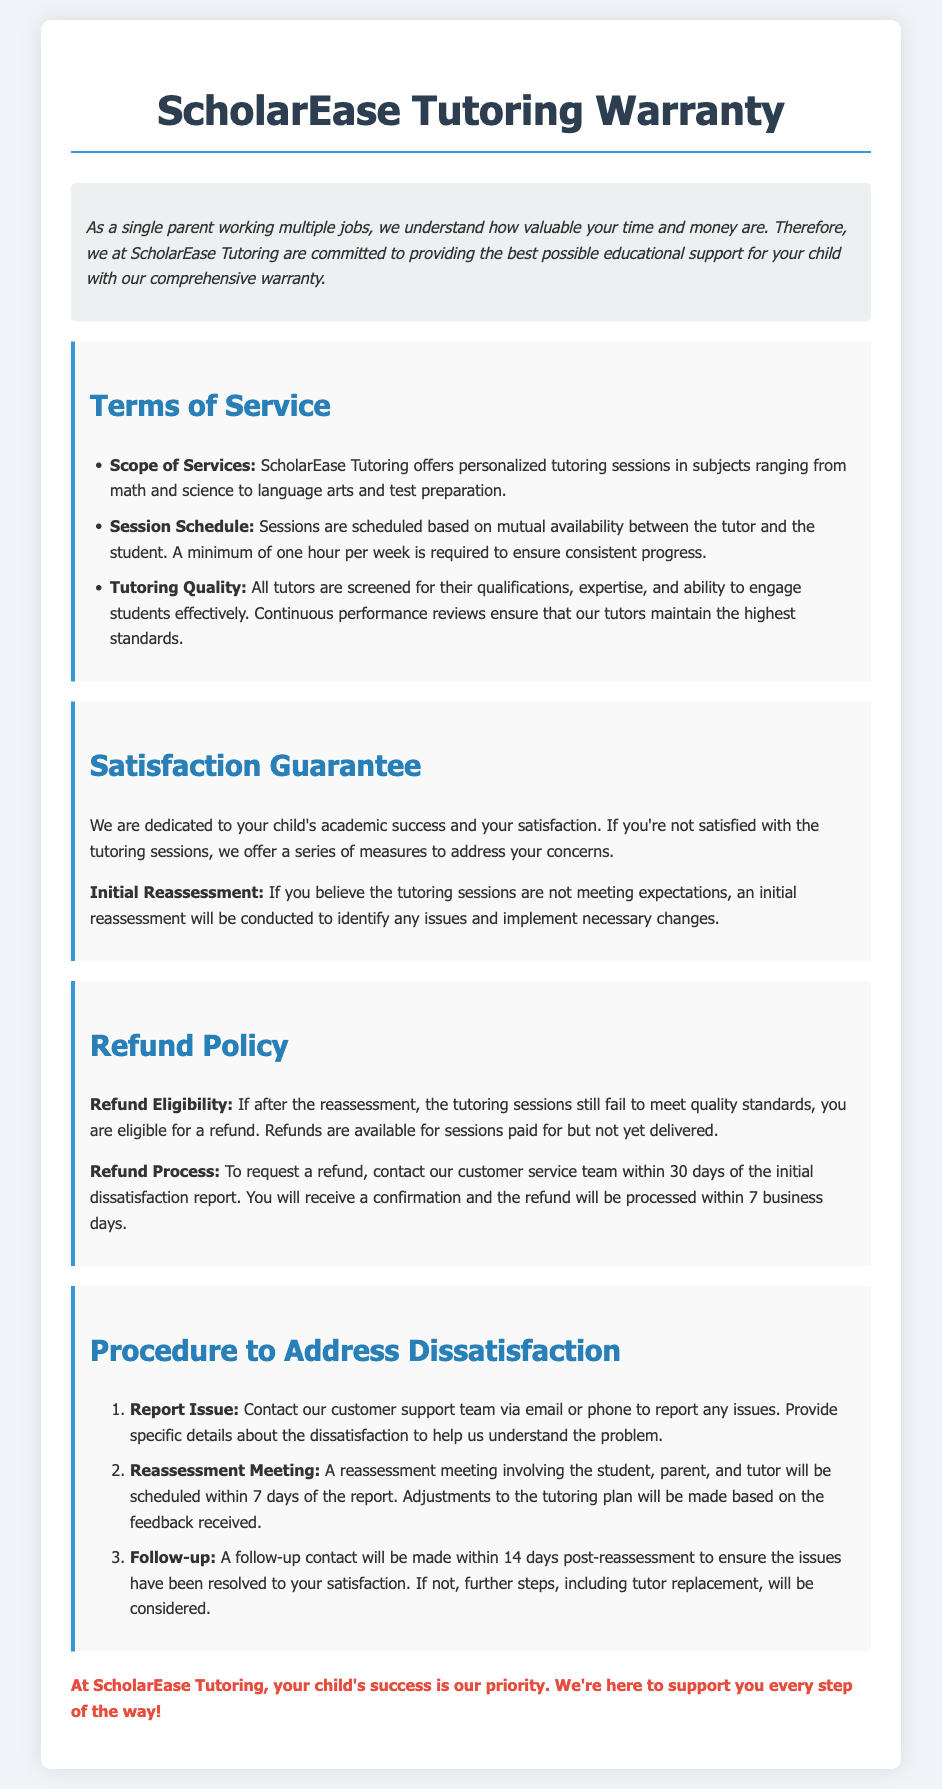What is the scope of services offered? The scope of services includes personalized tutoring sessions in subjects ranging from math and science to language arts and test preparation.
Answer: Personalized tutoring sessions in subjects ranging from math and science to language arts and test preparation What is the minimum session requirement? The document states that a minimum of one hour per week is required to ensure consistent progress.
Answer: One hour per week What happens if you are not satisfied with the tutoring sessions? The document mentions an initial reassessment will be conducted if you're not satisfied with the tutoring sessions to identify issues.
Answer: Initial reassessment How long do you have to request a refund? It is specified that you should contact customer service within 30 days of the initial dissatisfaction report to request a refund.
Answer: 30 days What is the time frame for processing refunds? According to the document, the refund will be processed within 7 business days after the request.
Answer: 7 business days What is involved in the follow-up procedure? A follow-up contact will be made within 14 days post-reassessment to ensure the issues have been resolved.
Answer: Within 14 days What type of tutoring quality assurance is provided? The document states that all tutors are screened for their qualifications, expertise, and ability to engage students effectively.
Answer: All tutors are screened for their qualifications, expertise, and ability to engage students effectively What is included in the procedure to address dissatisfaction? The procedure includes reporting the issue, having a reassessment meeting, and a follow-up contact.
Answer: Report issue, reassessment meeting, follow-up contact 